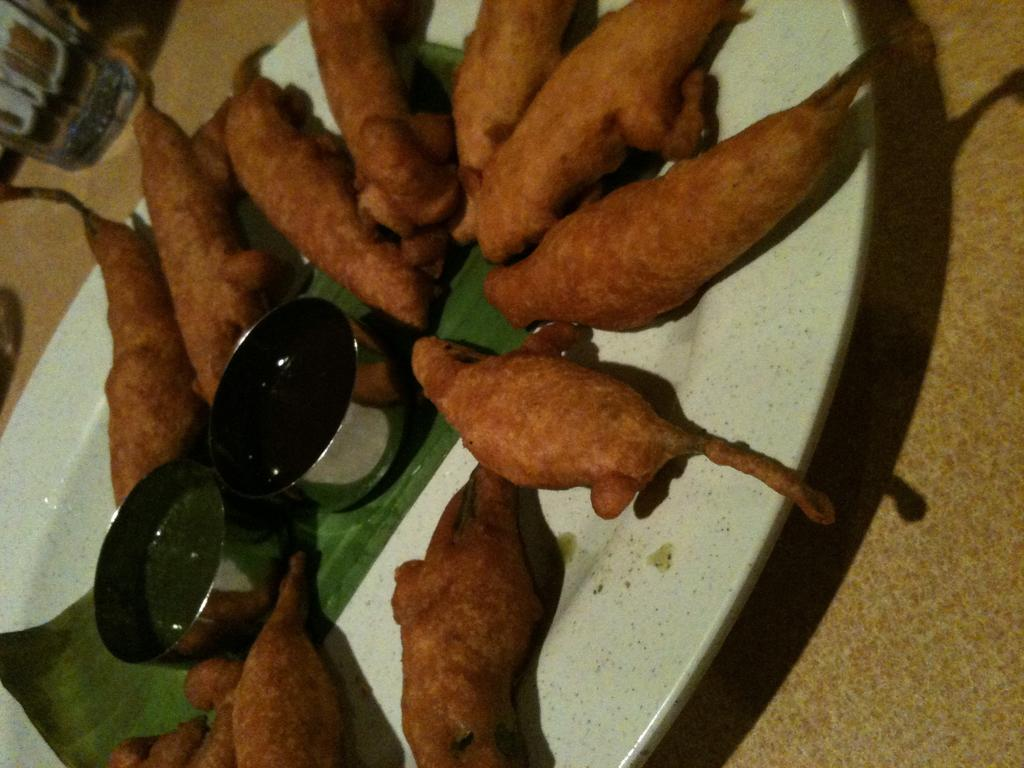What type of food can be seen in the image? The food in the image is in brown color. What color is the plate that holds the food? The plate is in white color. How many bowls are present on the plate? There are two bowls in the plate. Where are the cows located in the image? There are no cows present in the image. What type of tool is used to measure the weight of the food in the image? There is no tool for measuring weight, such as a scale, present in the image. 